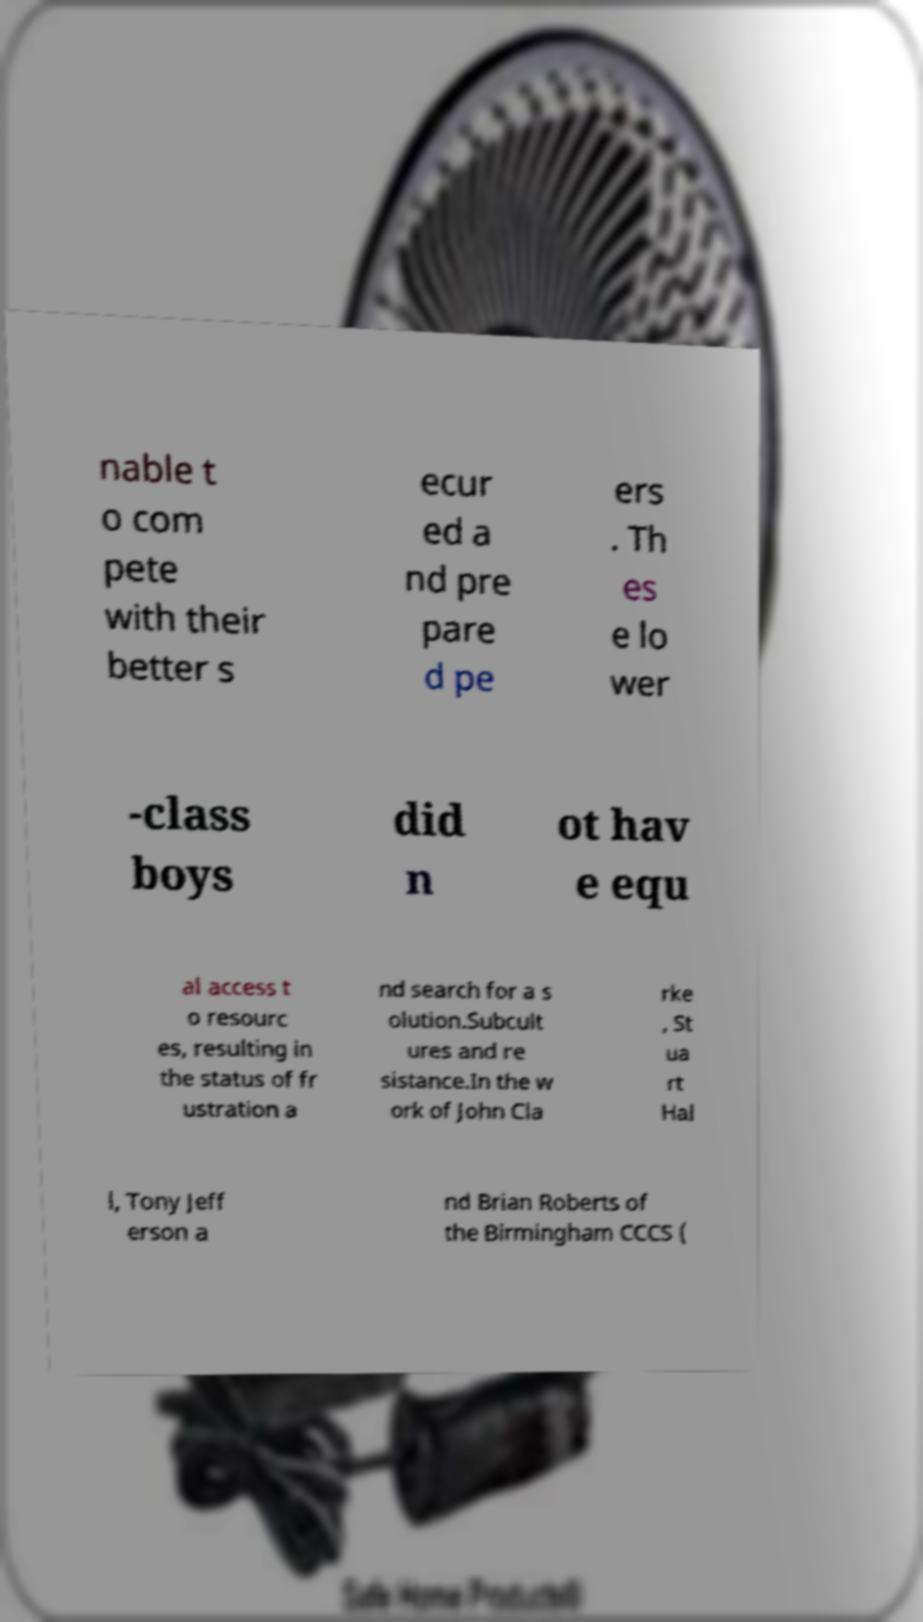Could you extract and type out the text from this image? nable t o com pete with their better s ecur ed a nd pre pare d pe ers . Th es e lo wer -class boys did n ot hav e equ al access t o resourc es, resulting in the status of fr ustration a nd search for a s olution.Subcult ures and re sistance.In the w ork of John Cla rke , St ua rt Hal l, Tony Jeff erson a nd Brian Roberts of the Birmingham CCCS ( 